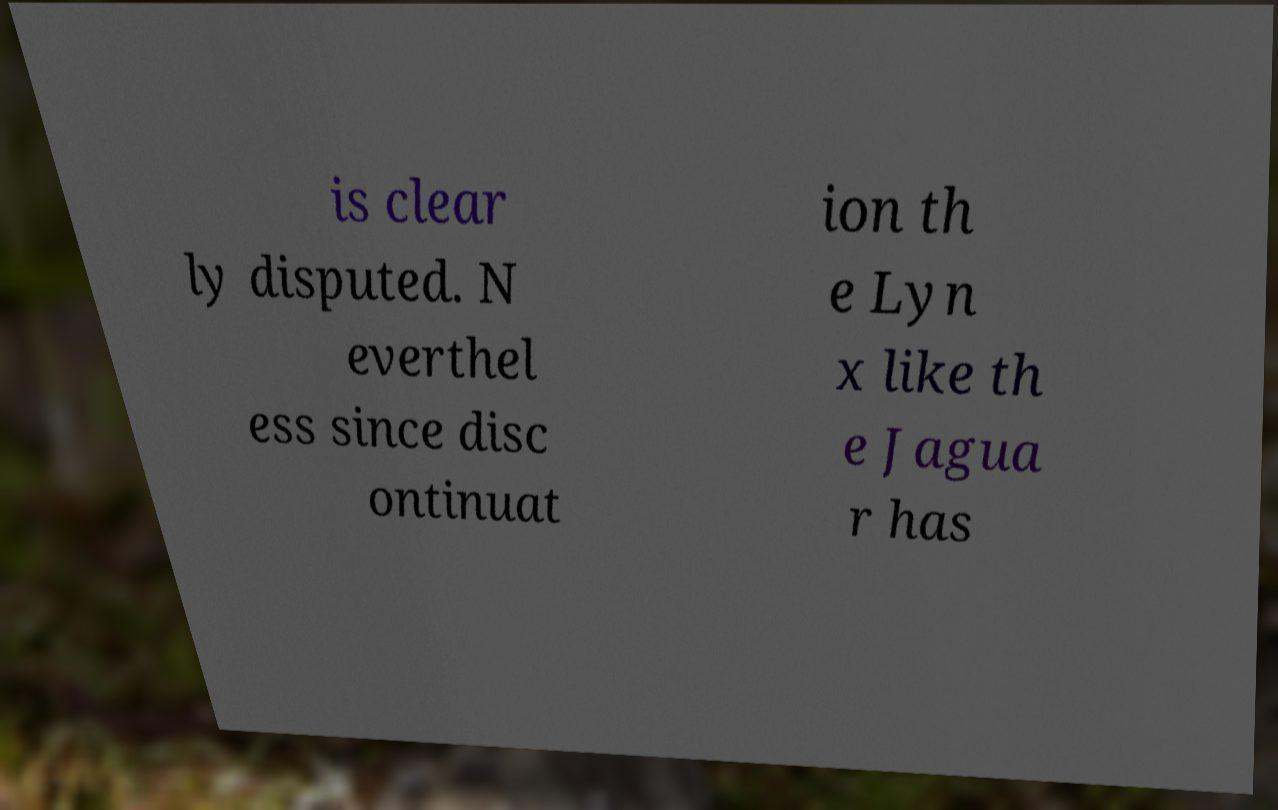There's text embedded in this image that I need extracted. Can you transcribe it verbatim? is clear ly disputed. N everthel ess since disc ontinuat ion th e Lyn x like th e Jagua r has 